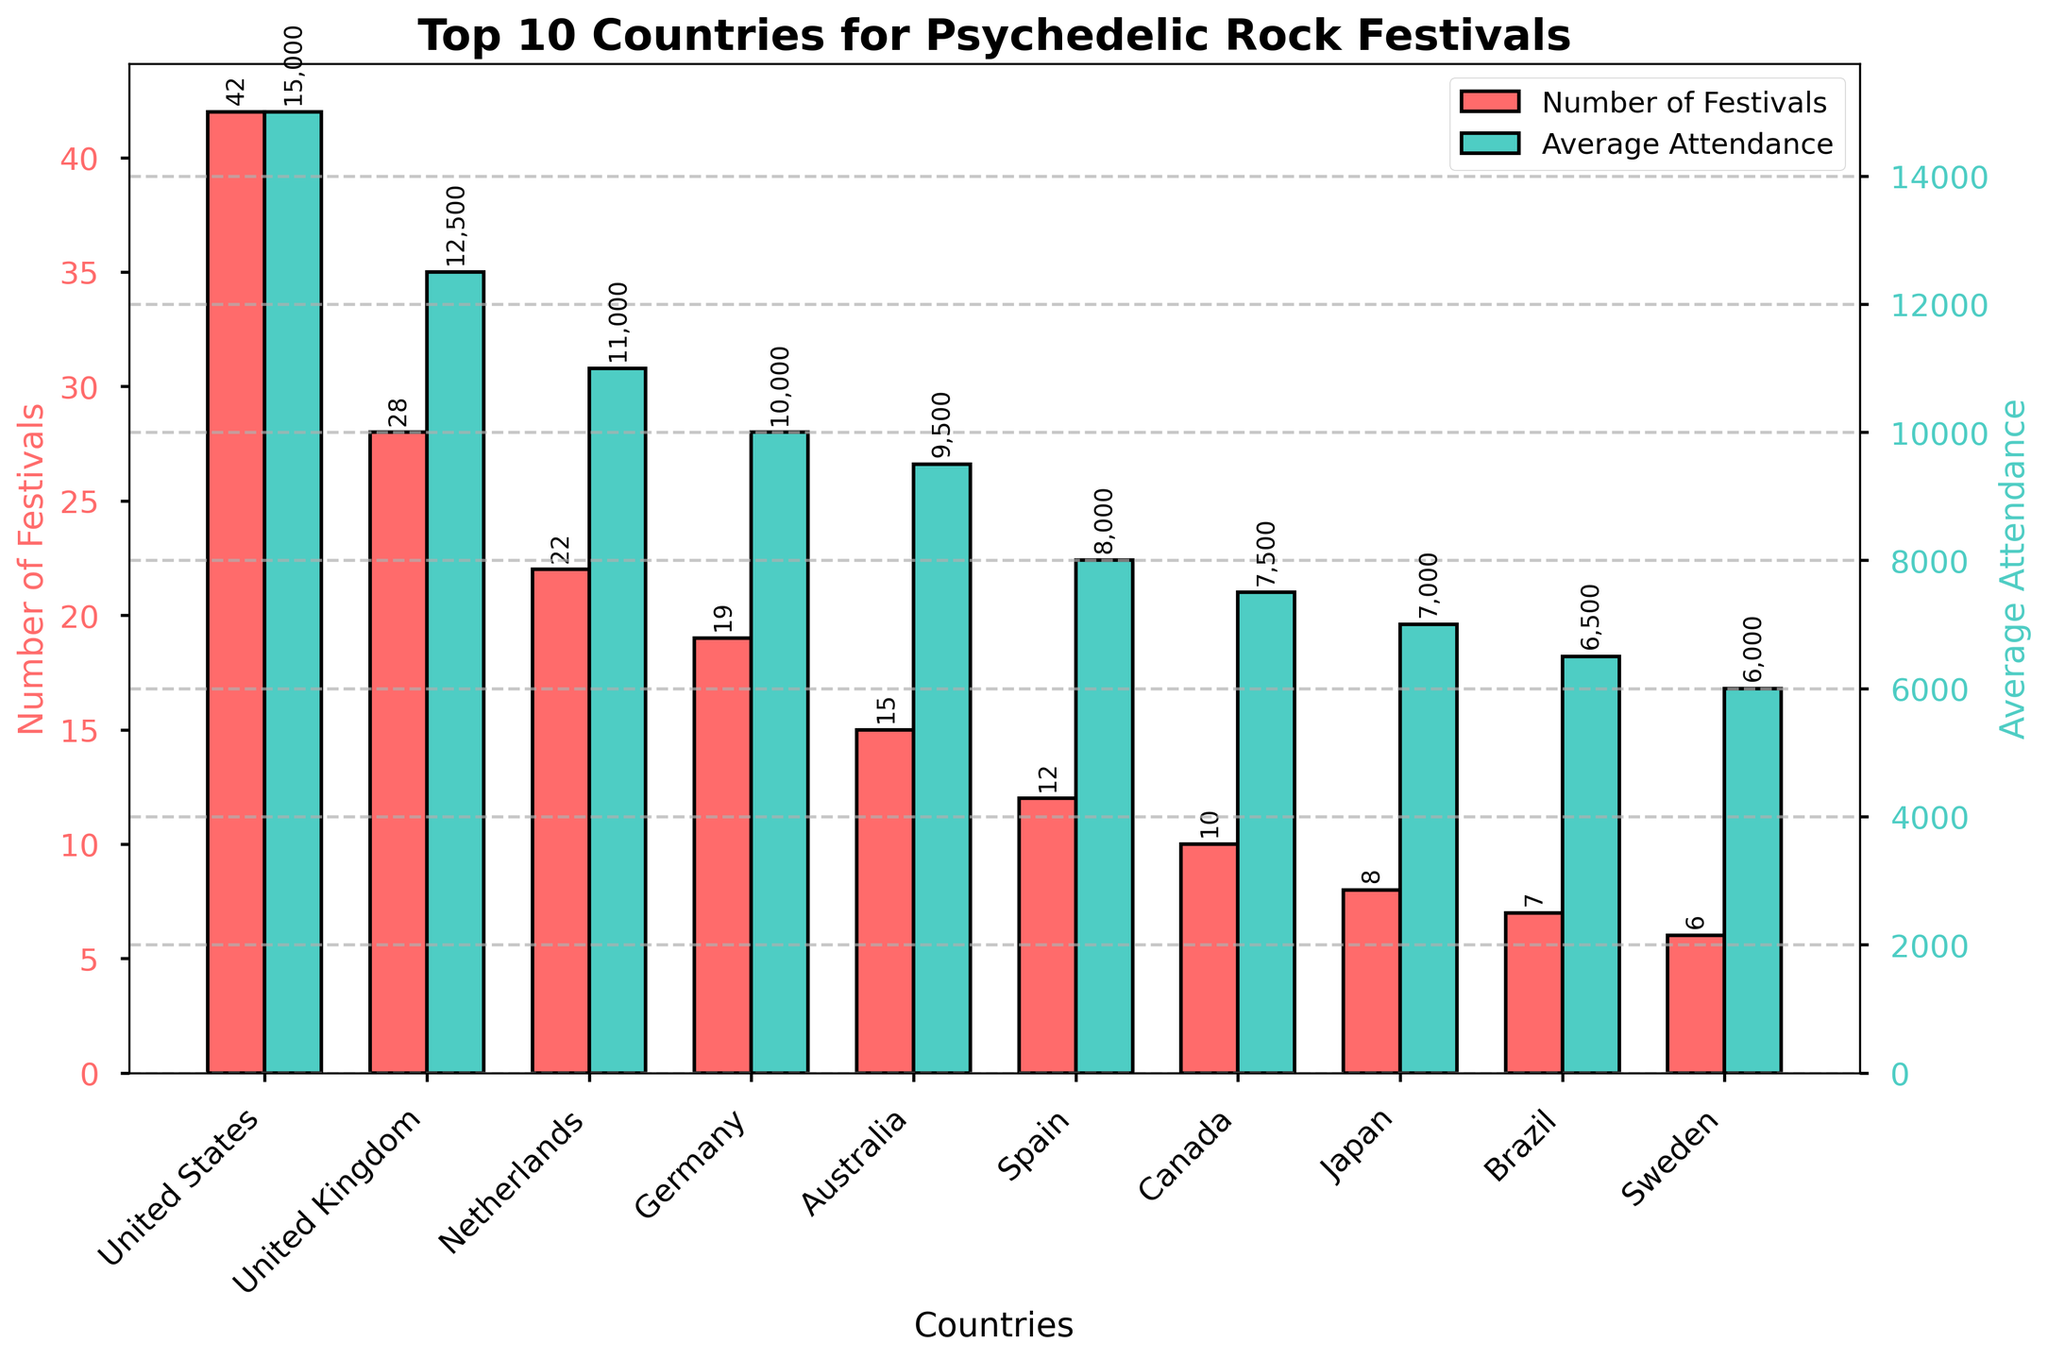How many more psychedelic rock festivals does the United States host compared to the United Kingdom? To find the difference, subtract the number of festivals in the United Kingdom (28) from the number in the United States (42). 42 - 28 = 14
Answer: 14 Which country has the highest average attendance, and what is that attendance? By examining the heights of the bars related to average attendance, the United States has the highest bar. The height, labeled, is 15,000
Answer: United States, 15,000 Are there any countries with the same number of psychedelic rock festivals? By comparing the heights of the bars representing the number of festivals, it's evident that no two countries share the same height.
Answer: No What is the sum of the number of festivals in Germany and Australia? Add the numbers for Germany (19) and Australia (15). 19 + 15 = 34
Answer: 34 How does the average attendance in Brazil compare to that in Sweden? By comparing the heights of the bars representing average attendance, Brazil’s average attendance is 6,500, whereas Sweden’s is 6,000. 6,500 - 6,000 = 500
Answer: Brazil has 500 more Which country has the least number of psychedelic rock festivals, and how many does it have? The shortest bar in the number of festivals category belongs to Sweden, which indicates it has the fewest festivals. The height labeled is 6.
Answer: Sweden, 6 For which country is the difference between the number of festivals and its average attendance the smallest? Calculate the difference for each country. The smallest difference can be found for Brazil: abs(7 - 6500) = 6,493. Inspecting other countries similarly confirms this.
Answer: Brazil What is the average number of festivals hosted by the top 3 countries combined? Sum the number of festivals for the United States (42), United Kingdom (28), and Netherlands (22), then divide by 3. (42 + 28 + 22) / 3 = 30.67
Answer: 30.67 